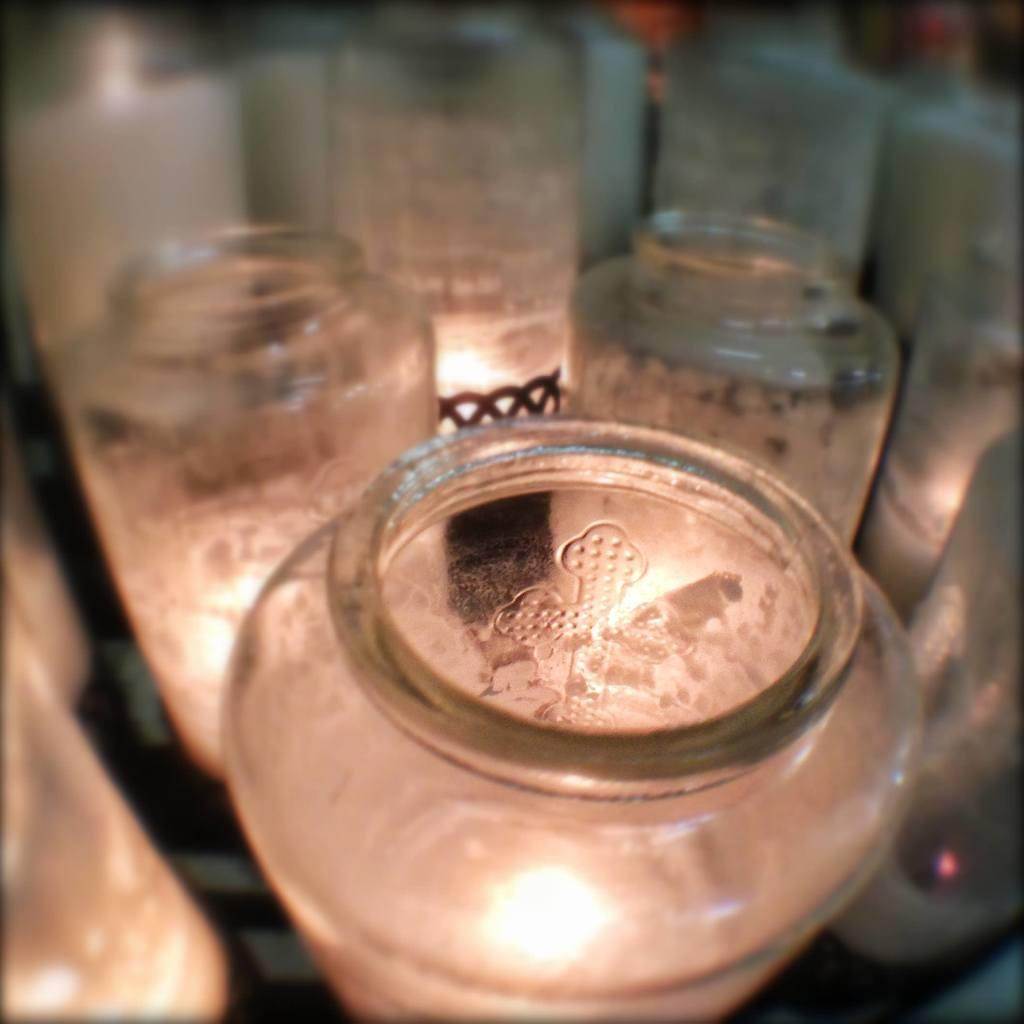What type of containers are visible in the image? There are glass bottles in the image. Are the glass bottles filled with any liquid or substance? No, the glass bottles are empty. Where are the glass bottles located in the image? The glass bottles are on the floor. Can you determine the setting of the image based on the available information? The image is likely taken inside a room, as there is no indication of an outdoor setting. How does the glass bottle support the profit of the company in the image? There is no information about a company or profit in the image; it only shows empty glass bottles on the floor. 